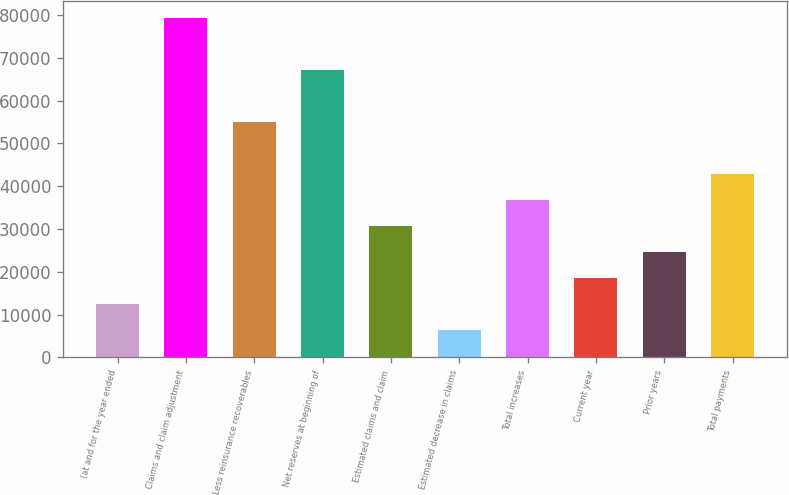<chart> <loc_0><loc_0><loc_500><loc_500><bar_chart><fcel>(at and for the year ended<fcel>Claims and claim adjustment<fcel>Less reinsurance recoverables<fcel>Net reserves at beginning of<fcel>Estimated claims and claim<fcel>Estimated decrease in claims<fcel>Total increases<fcel>Current year<fcel>Prior years<fcel>Total payments<nl><fcel>12375.8<fcel>79243.7<fcel>54928.1<fcel>67085.9<fcel>30612.5<fcel>6296.9<fcel>36691.4<fcel>18454.7<fcel>24533.6<fcel>42770.3<nl></chart> 